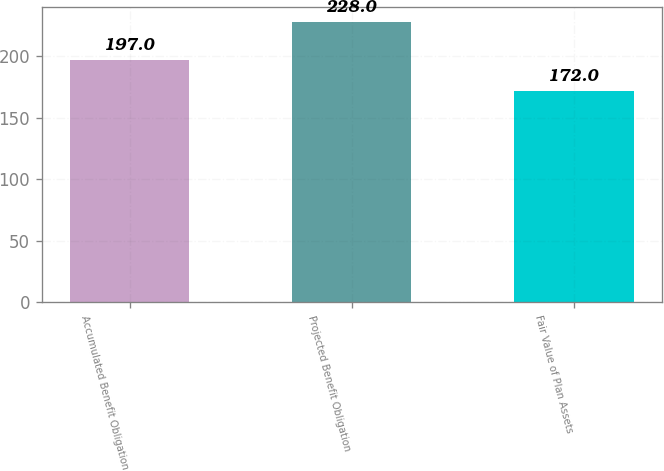<chart> <loc_0><loc_0><loc_500><loc_500><bar_chart><fcel>Accumulated Benefit Obligation<fcel>Projected Benefit Obligation<fcel>Fair Value of Plan Assets<nl><fcel>197<fcel>228<fcel>172<nl></chart> 